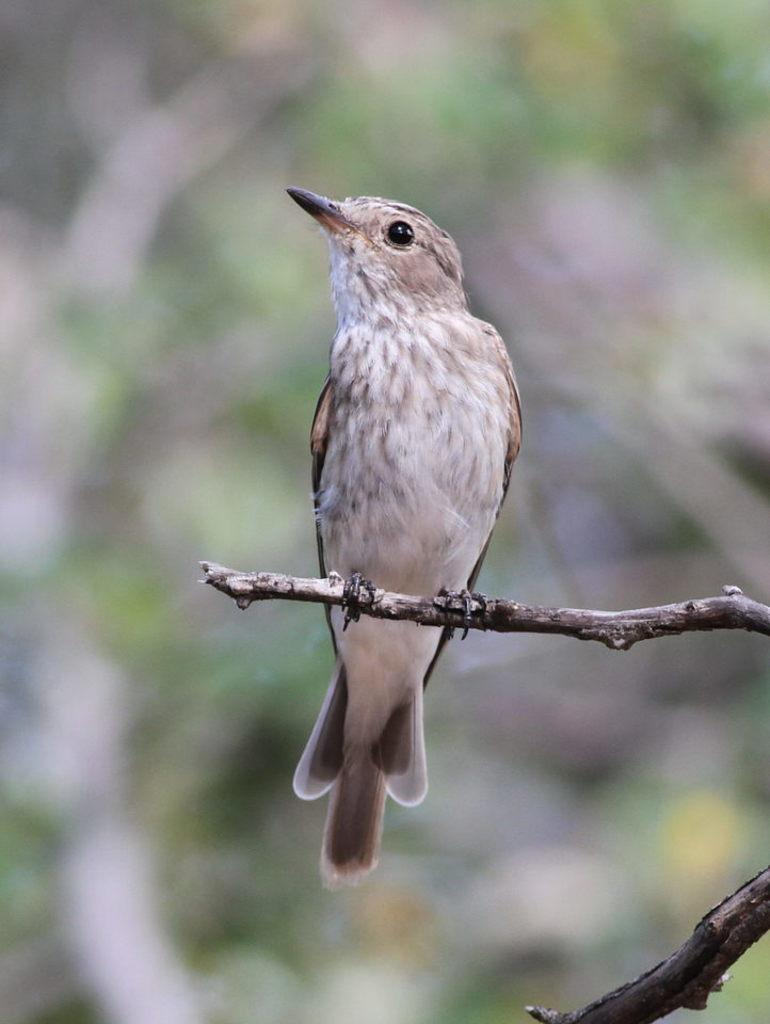What is the bird doing in the image? The bird is sitting on a branch in the image. What can be seen behind the bird? The background of the bird is blue. What type of cannon is present in the image? There is no cannon present in the image; it features a bird sitting on a branch with a blue background. What government-related object can be seen in the image? There are no government-related objects present in the image. 